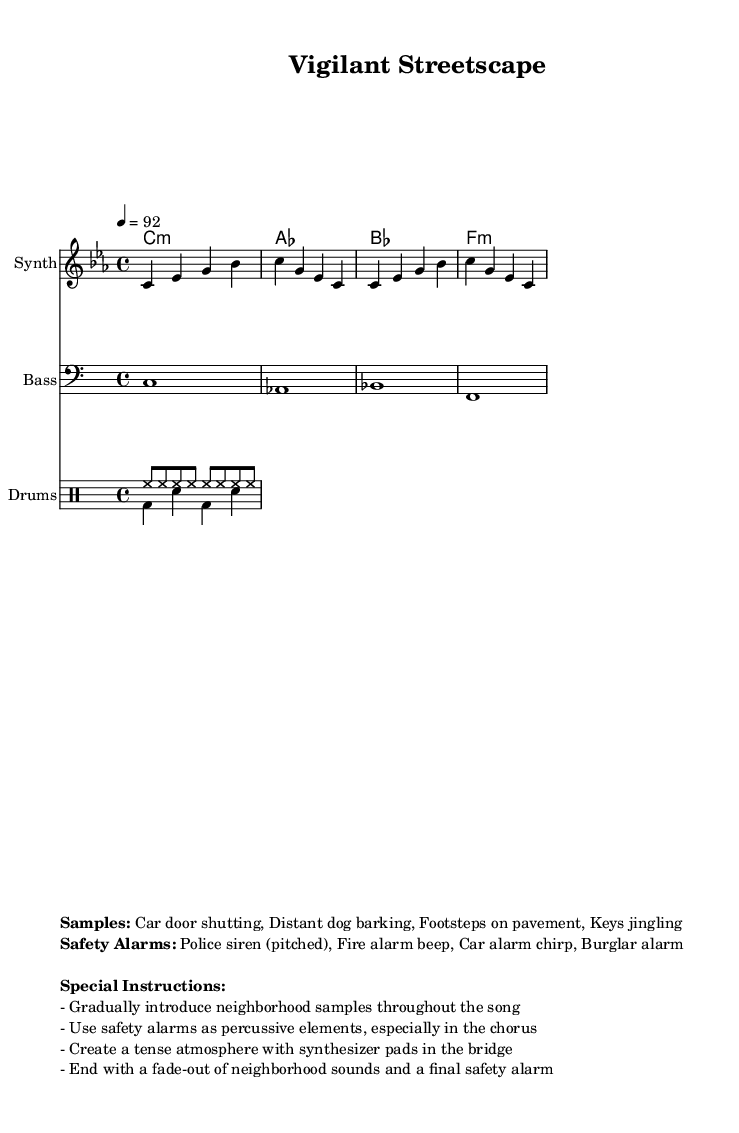What is the key signature of this music? The key signature is C minor, which has three flats (B♭, E♭, A♭). This can be determined from the 'global' block in the code, where it specifies \key c \minor.
Answer: C minor What is the time signature of the piece? The time signature is 4/4, which means there are four beats in a measure and the quarter note gets one beat. This is indicated in the 'global' block of the code as \time 4/4.
Answer: 4/4 What is the tempo marking of this piece? The tempo marking is 92 beats per minute, indicated by the command \tempo 4 = 92 in the 'global' block.
Answer: 92 What type of drum pattern is used in the piece? The drum patterns consist of a high-hat pattern and a kick-snare pattern. The high-hat is played consistently with eighth notes in 'drumPatternUp,' while the kick-snare pattern has quarter notes in 'drumPatternDown'.
Answer: High-hat and kick-snare What specific neighborhood sounds are mentioned in the score? The neighborhood sounds listed are 'Car door shutting, Distant dog barking, Footsteps on pavement, Keys jingling.' These samples are included in the 'markup' section under 'Samples'.
Answer: Car door shutting, Distant dog barking, Footsteps on pavement, Keys jingling How is the atmosphere intended to be created in the bridge section? The atmosphere in the bridge section is meant to be tense, as instructed by the special instructions which say to use synthesizer pads during this section. This helps build an emotional intensity within the piece.
Answer: Tense atmosphere with synthesizer pads 